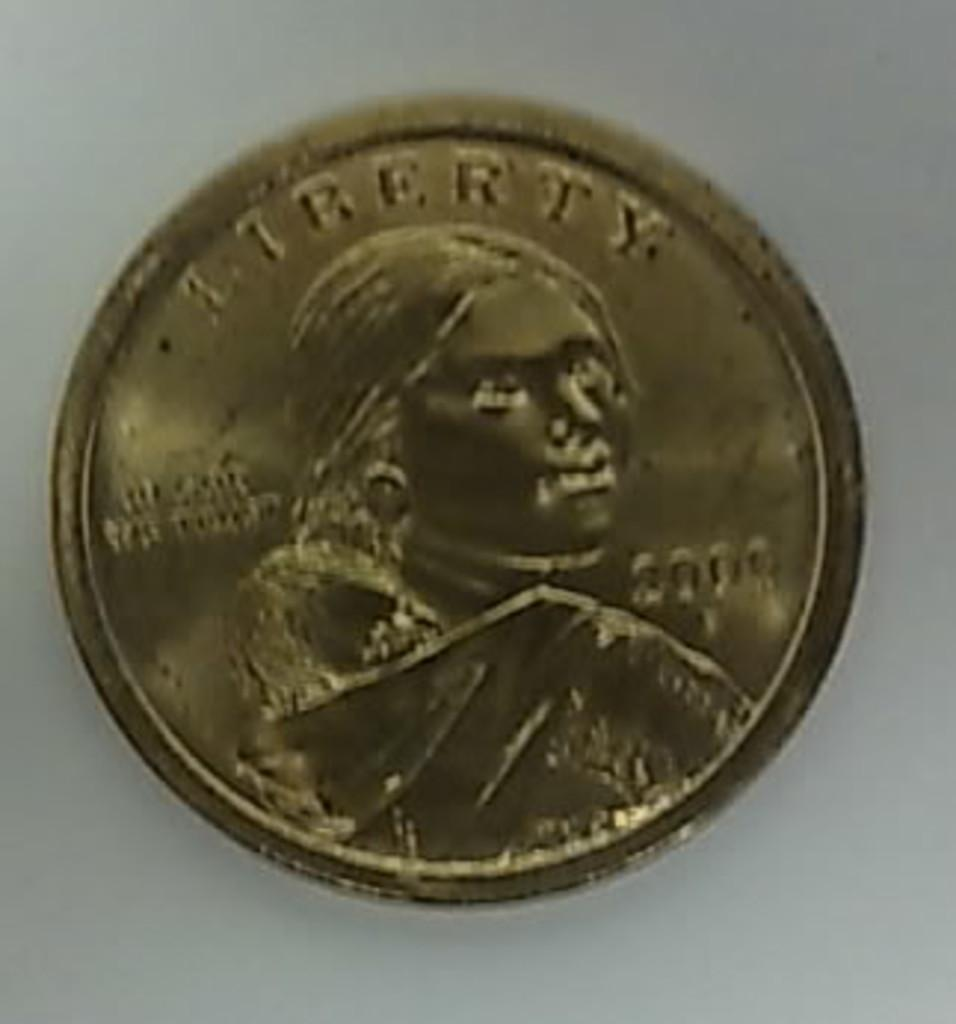What is the main object in the picture? There is a gold coin in the picture. What is depicted on the gold coin? There is a photo of a woman on the gold coin. What type of ice can be seen melting on the tail of the sock in the image? There is no ice, tail, or sock present in the image; it only features a gold coin with a photo of a woman. 